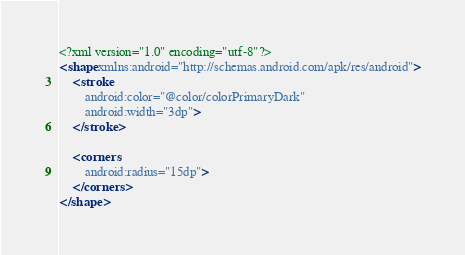<code> <loc_0><loc_0><loc_500><loc_500><_XML_><?xml version="1.0" encoding="utf-8"?>
<shape xmlns:android="http://schemas.android.com/apk/res/android">
    <stroke
        android:color="@color/colorPrimaryDark"
        android:width="3dp">
    </stroke>

    <corners
        android:radius="15dp">
    </corners>
</shape></code> 